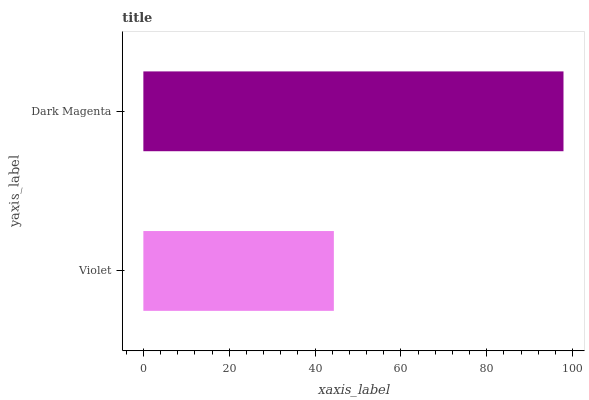Is Violet the minimum?
Answer yes or no. Yes. Is Dark Magenta the maximum?
Answer yes or no. Yes. Is Dark Magenta the minimum?
Answer yes or no. No. Is Dark Magenta greater than Violet?
Answer yes or no. Yes. Is Violet less than Dark Magenta?
Answer yes or no. Yes. Is Violet greater than Dark Magenta?
Answer yes or no. No. Is Dark Magenta less than Violet?
Answer yes or no. No. Is Dark Magenta the high median?
Answer yes or no. Yes. Is Violet the low median?
Answer yes or no. Yes. Is Violet the high median?
Answer yes or no. No. Is Dark Magenta the low median?
Answer yes or no. No. 